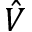<formula> <loc_0><loc_0><loc_500><loc_500>\hat { V }</formula> 